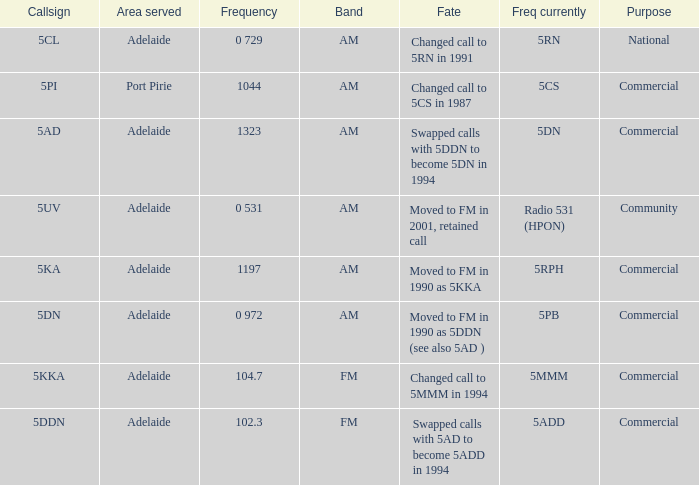Which area served has a Callsign of 5ddn? Adelaide. 